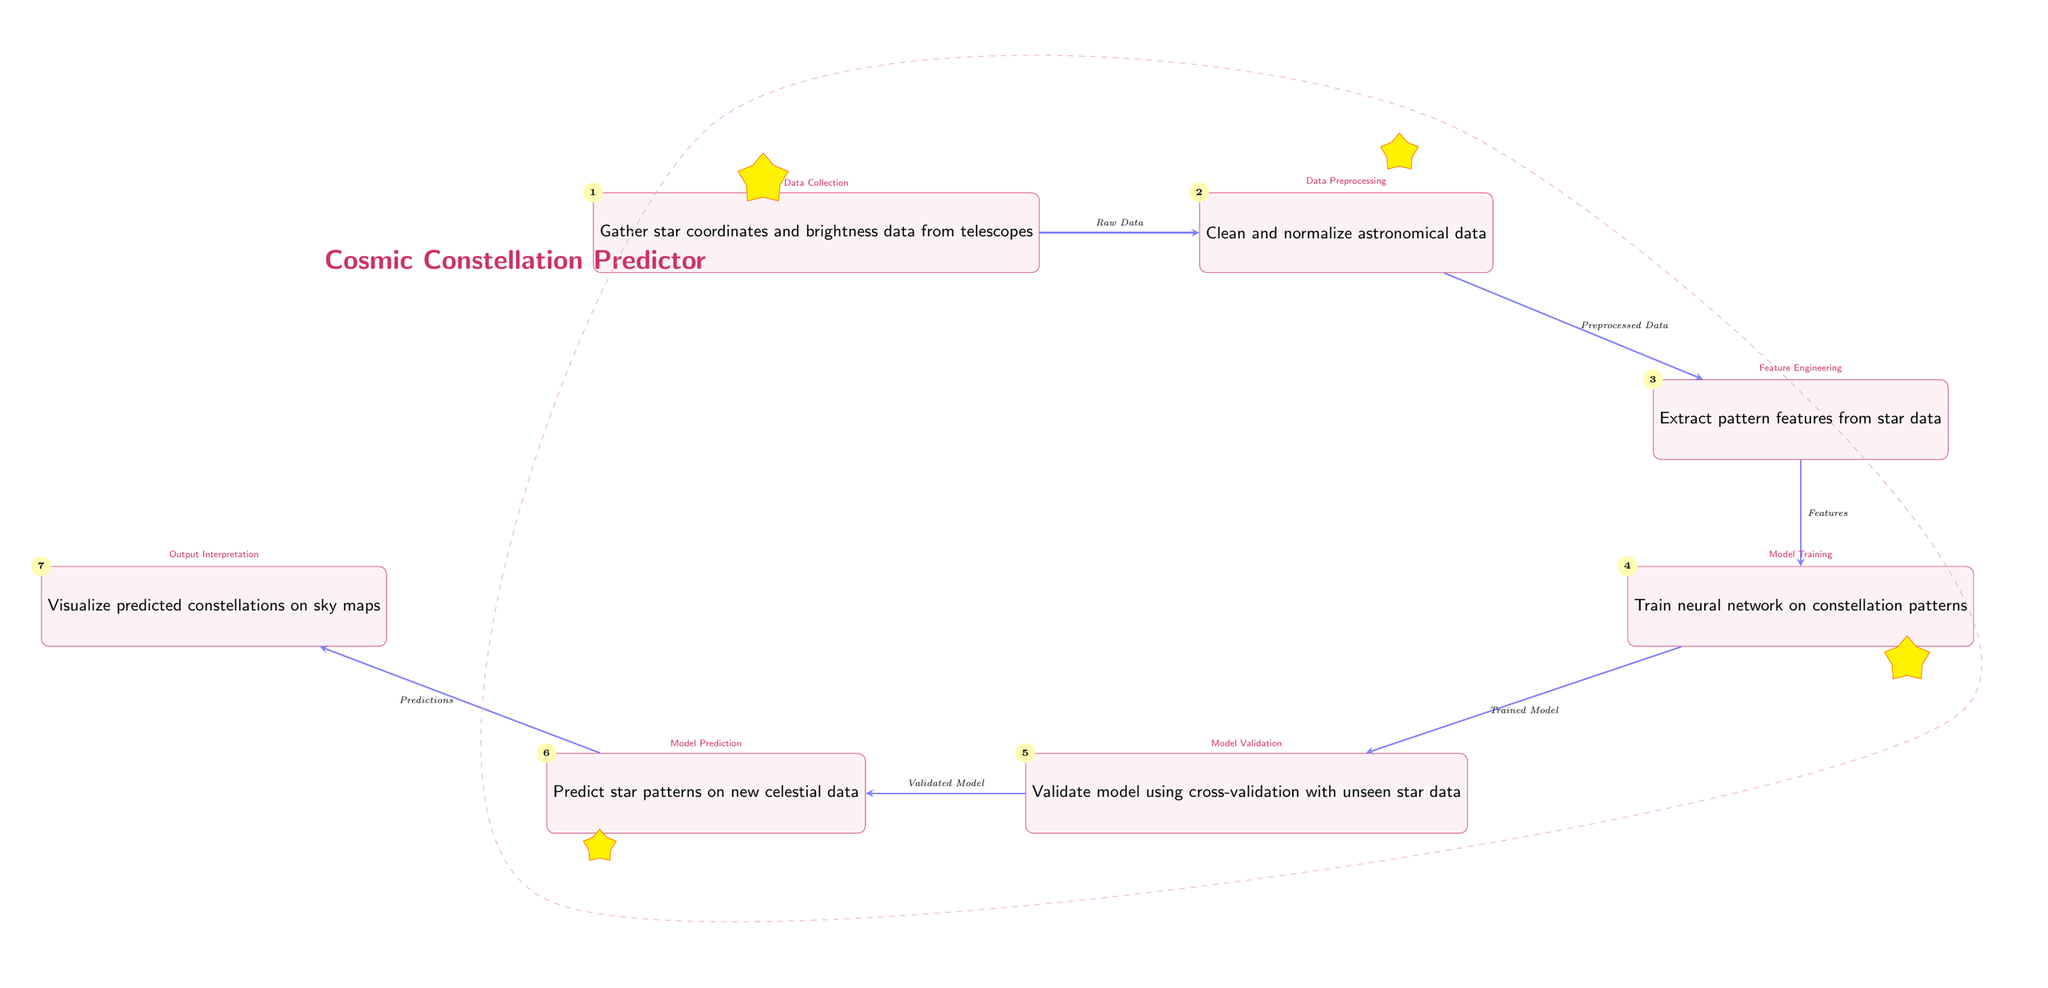What type of data is gathered first in the diagram? The first step in the diagram is to gather star coordinates and brightness data from telescopes. This is indicated by the first node, which describes data collection.
Answer: star coordinates and brightness data What is the second step after gathering data? The second step in the diagram is cleaning and normalizing astronomical data, as shown in the second node which directly follows the first node.
Answer: Clean and normalize astronomical data How many nodes are present in the diagram? By counting the nodes depicted in the diagram, there are a total of seven nodes that represent different steps of the process.
Answer: 7 What is the output of the model? The final output of the model, as indicated in the last node of the diagram, is visualizing predicted constellations on sky maps.
Answer: Visualize predicted constellations on sky maps Which node comes after validating the model? The node that comes after validating the model is the one that predicts star patterns on new celestial data, indicating continual progression in the process flow.
Answer: Predict star patterns on new celestial data What type of machine learning method is indicated by the fourth node in the diagram? The fourth node states that a neural network is trained on constellation patterns, which is a type of machine learning method focused on pattern recognition.
Answer: Train neural network What is the relationship between the first and second nodes? The relationship between the first and second nodes is that the second node processes the output from the first node, which is the raw data collected at the beginning.
Answer: Raw Data to Preprocessed Data Which step is involved in evaluating the model's accuracy? The validation of the model using cross-validation with unseen star data is the step that involves evaluating the model’s accuracy, as indicated in the fifth node.
Answer: Validate model using cross-validation What is the purpose of the arrows in this diagram? The arrows in the diagram indicate the flow of process steps, showing how the output from one node becomes the input for the next node, thus guiding the workflow.
Answer: Indicate process flow 